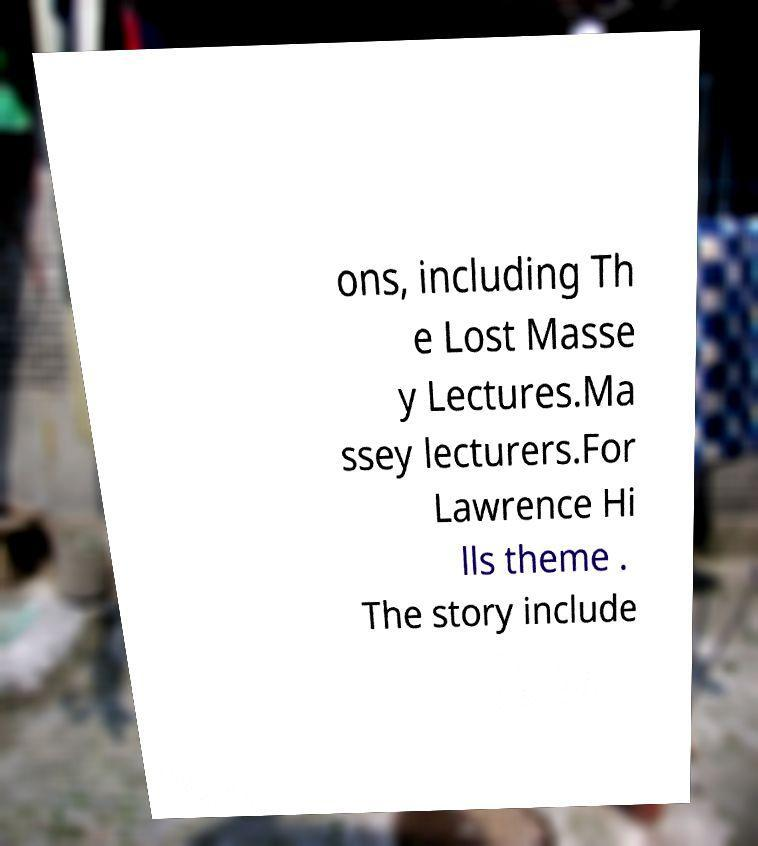Can you read and provide the text displayed in the image?This photo seems to have some interesting text. Can you extract and type it out for me? ons, including Th e Lost Masse y Lectures.Ma ssey lecturers.For Lawrence Hi lls theme . The story include 